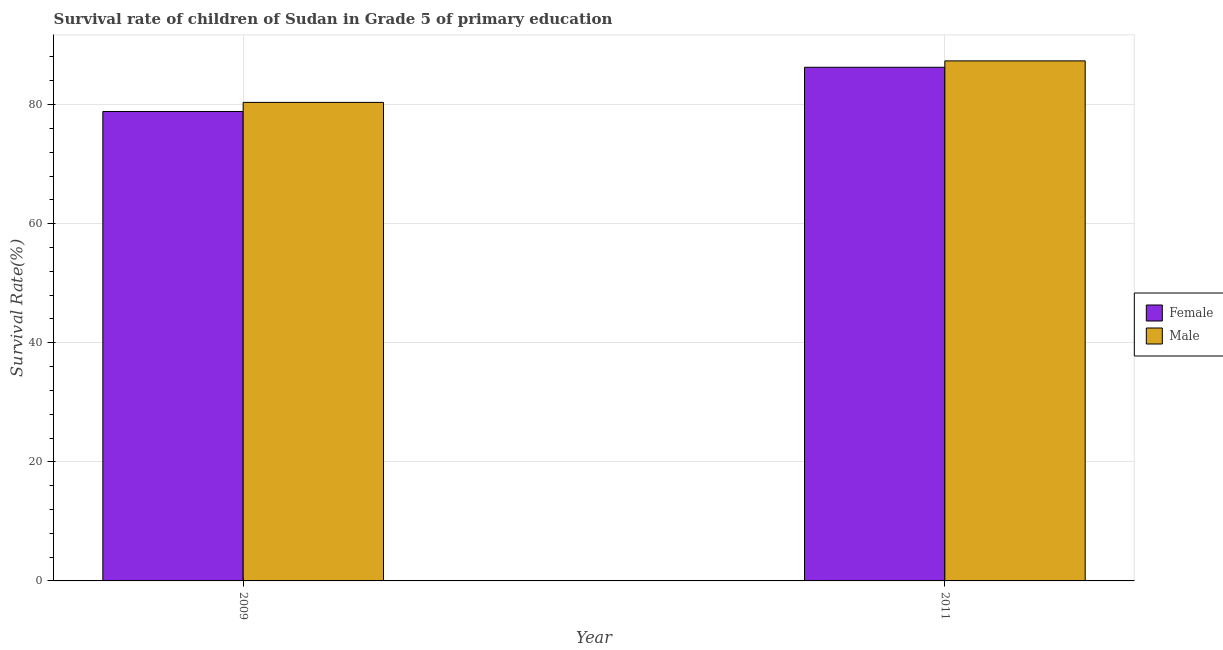Are the number of bars on each tick of the X-axis equal?
Ensure brevity in your answer.  Yes. How many bars are there on the 1st tick from the right?
Your response must be concise. 2. What is the survival rate of male students in primary education in 2009?
Keep it short and to the point. 80.36. Across all years, what is the maximum survival rate of female students in primary education?
Provide a succinct answer. 86.26. Across all years, what is the minimum survival rate of female students in primary education?
Offer a very short reply. 78.84. In which year was the survival rate of female students in primary education maximum?
Give a very brief answer. 2011. What is the total survival rate of female students in primary education in the graph?
Offer a terse response. 165.1. What is the difference between the survival rate of male students in primary education in 2009 and that in 2011?
Give a very brief answer. -6.97. What is the difference between the survival rate of female students in primary education in 2011 and the survival rate of male students in primary education in 2009?
Your response must be concise. 7.42. What is the average survival rate of female students in primary education per year?
Make the answer very short. 82.55. In how many years, is the survival rate of male students in primary education greater than 60 %?
Your answer should be compact. 2. What is the ratio of the survival rate of male students in primary education in 2009 to that in 2011?
Give a very brief answer. 0.92. In how many years, is the survival rate of male students in primary education greater than the average survival rate of male students in primary education taken over all years?
Your answer should be very brief. 1. How many years are there in the graph?
Make the answer very short. 2. What is the difference between two consecutive major ticks on the Y-axis?
Offer a terse response. 20. Does the graph contain grids?
Your answer should be very brief. Yes. How many legend labels are there?
Your response must be concise. 2. What is the title of the graph?
Offer a terse response. Survival rate of children of Sudan in Grade 5 of primary education. What is the label or title of the Y-axis?
Your answer should be compact. Survival Rate(%). What is the Survival Rate(%) of Female in 2009?
Keep it short and to the point. 78.84. What is the Survival Rate(%) in Male in 2009?
Your answer should be compact. 80.36. What is the Survival Rate(%) of Female in 2011?
Your answer should be very brief. 86.26. What is the Survival Rate(%) in Male in 2011?
Offer a terse response. 87.34. Across all years, what is the maximum Survival Rate(%) of Female?
Offer a very short reply. 86.26. Across all years, what is the maximum Survival Rate(%) of Male?
Provide a succinct answer. 87.34. Across all years, what is the minimum Survival Rate(%) in Female?
Your answer should be compact. 78.84. Across all years, what is the minimum Survival Rate(%) of Male?
Make the answer very short. 80.36. What is the total Survival Rate(%) in Female in the graph?
Offer a terse response. 165.1. What is the total Survival Rate(%) of Male in the graph?
Give a very brief answer. 167.7. What is the difference between the Survival Rate(%) in Female in 2009 and that in 2011?
Ensure brevity in your answer.  -7.42. What is the difference between the Survival Rate(%) of Male in 2009 and that in 2011?
Provide a short and direct response. -6.97. What is the difference between the Survival Rate(%) of Female in 2009 and the Survival Rate(%) of Male in 2011?
Provide a succinct answer. -8.5. What is the average Survival Rate(%) in Female per year?
Provide a short and direct response. 82.55. What is the average Survival Rate(%) of Male per year?
Offer a very short reply. 83.85. In the year 2009, what is the difference between the Survival Rate(%) of Female and Survival Rate(%) of Male?
Provide a short and direct response. -1.52. In the year 2011, what is the difference between the Survival Rate(%) in Female and Survival Rate(%) in Male?
Provide a succinct answer. -1.07. What is the ratio of the Survival Rate(%) of Female in 2009 to that in 2011?
Make the answer very short. 0.91. What is the ratio of the Survival Rate(%) in Male in 2009 to that in 2011?
Provide a short and direct response. 0.92. What is the difference between the highest and the second highest Survival Rate(%) of Female?
Offer a terse response. 7.42. What is the difference between the highest and the second highest Survival Rate(%) of Male?
Offer a terse response. 6.97. What is the difference between the highest and the lowest Survival Rate(%) in Female?
Make the answer very short. 7.42. What is the difference between the highest and the lowest Survival Rate(%) of Male?
Give a very brief answer. 6.97. 